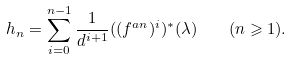<formula> <loc_0><loc_0><loc_500><loc_500>h _ { n } = \sum _ { i = 0 } ^ { n - 1 } \frac { 1 } { d ^ { i + 1 } } ( ( f ^ { a n } ) ^ { i } ) ^ { * } ( \lambda ) \quad ( n \geqslant 1 ) .</formula> 